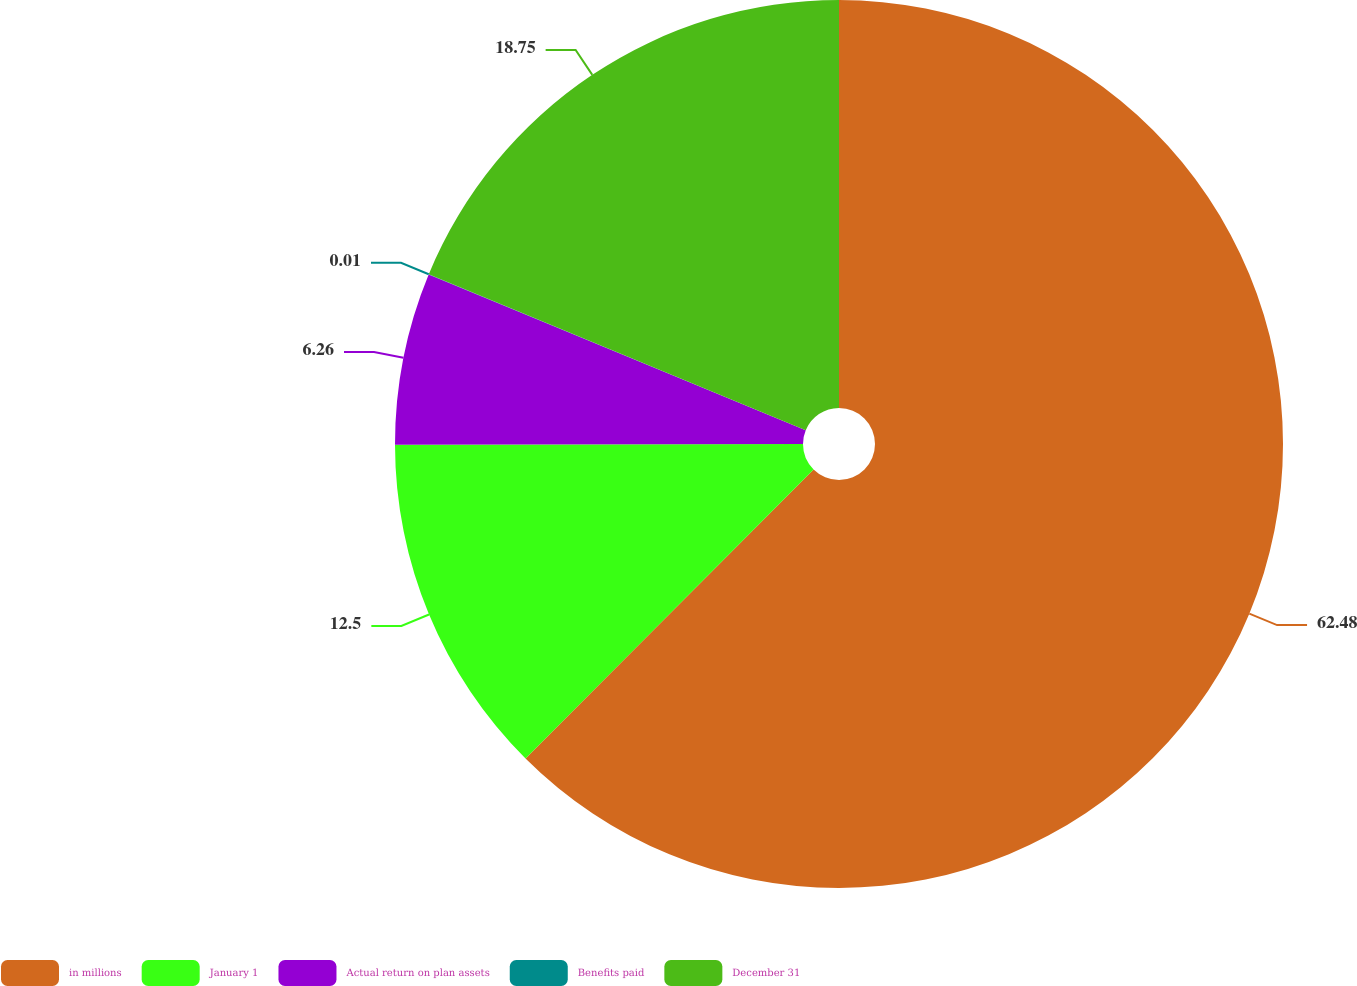Convert chart. <chart><loc_0><loc_0><loc_500><loc_500><pie_chart><fcel>in millions<fcel>January 1<fcel>Actual return on plan assets<fcel>Benefits paid<fcel>December 31<nl><fcel>62.47%<fcel>12.5%<fcel>6.26%<fcel>0.01%<fcel>18.75%<nl></chart> 